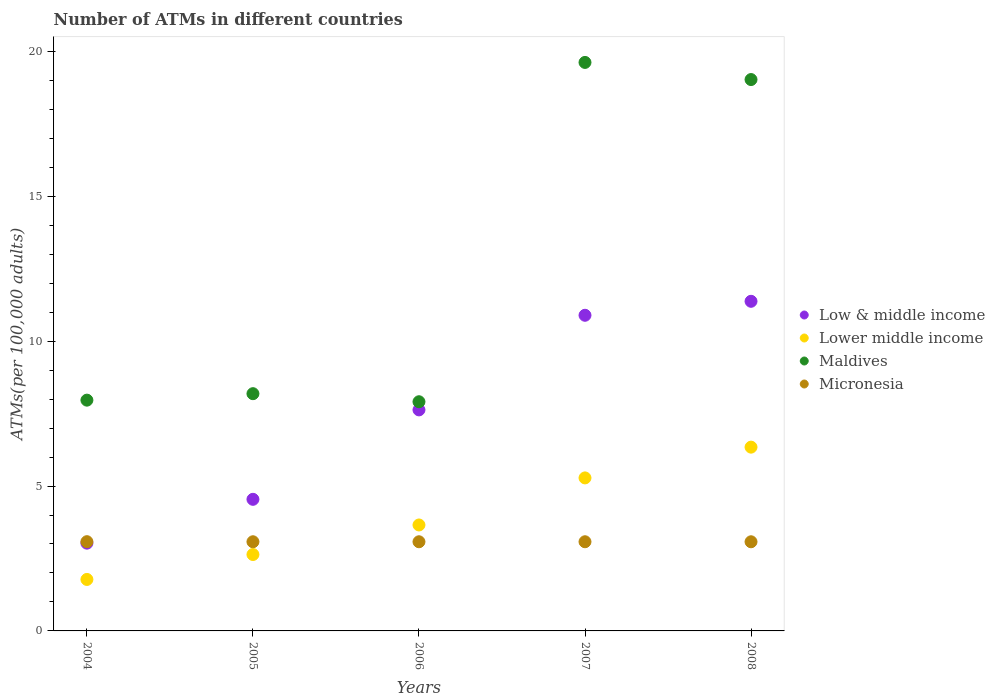Is the number of dotlines equal to the number of legend labels?
Provide a short and direct response. Yes. What is the number of ATMs in Maldives in 2006?
Your answer should be compact. 7.91. Across all years, what is the maximum number of ATMs in Lower middle income?
Give a very brief answer. 6.34. Across all years, what is the minimum number of ATMs in Lower middle income?
Provide a succinct answer. 1.78. In which year was the number of ATMs in Lower middle income maximum?
Your response must be concise. 2008. In which year was the number of ATMs in Maldives minimum?
Provide a short and direct response. 2006. What is the total number of ATMs in Maldives in the graph?
Give a very brief answer. 62.71. What is the difference between the number of ATMs in Maldives in 2005 and that in 2007?
Provide a short and direct response. -11.43. What is the difference between the number of ATMs in Maldives in 2008 and the number of ATMs in Low & middle income in 2007?
Provide a short and direct response. 8.13. What is the average number of ATMs in Maldives per year?
Give a very brief answer. 12.54. In the year 2006, what is the difference between the number of ATMs in Maldives and number of ATMs in Low & middle income?
Keep it short and to the point. 0.28. What is the ratio of the number of ATMs in Low & middle income in 2005 to that in 2007?
Your answer should be compact. 0.42. Is the number of ATMs in Micronesia in 2004 less than that in 2006?
Give a very brief answer. No. Is the difference between the number of ATMs in Maldives in 2004 and 2006 greater than the difference between the number of ATMs in Low & middle income in 2004 and 2006?
Make the answer very short. Yes. What is the difference between the highest and the second highest number of ATMs in Micronesia?
Give a very brief answer. 0. What is the difference between the highest and the lowest number of ATMs in Maldives?
Ensure brevity in your answer.  11.71. Is it the case that in every year, the sum of the number of ATMs in Maldives and number of ATMs in Lower middle income  is greater than the number of ATMs in Low & middle income?
Your answer should be very brief. Yes. How many dotlines are there?
Provide a short and direct response. 4. How many years are there in the graph?
Ensure brevity in your answer.  5. What is the difference between two consecutive major ticks on the Y-axis?
Make the answer very short. 5. Are the values on the major ticks of Y-axis written in scientific E-notation?
Ensure brevity in your answer.  No. Does the graph contain any zero values?
Offer a terse response. No. What is the title of the graph?
Your response must be concise. Number of ATMs in different countries. What is the label or title of the X-axis?
Provide a short and direct response. Years. What is the label or title of the Y-axis?
Give a very brief answer. ATMs(per 100,0 adults). What is the ATMs(per 100,000 adults) of Low & middle income in 2004?
Keep it short and to the point. 3.03. What is the ATMs(per 100,000 adults) of Lower middle income in 2004?
Provide a succinct answer. 1.78. What is the ATMs(per 100,000 adults) in Maldives in 2004?
Your answer should be compact. 7.96. What is the ATMs(per 100,000 adults) in Micronesia in 2004?
Your answer should be compact. 3.08. What is the ATMs(per 100,000 adults) of Low & middle income in 2005?
Your answer should be very brief. 4.54. What is the ATMs(per 100,000 adults) of Lower middle income in 2005?
Your answer should be very brief. 2.64. What is the ATMs(per 100,000 adults) of Maldives in 2005?
Make the answer very short. 8.19. What is the ATMs(per 100,000 adults) in Micronesia in 2005?
Provide a short and direct response. 3.08. What is the ATMs(per 100,000 adults) of Low & middle income in 2006?
Offer a terse response. 7.63. What is the ATMs(per 100,000 adults) of Lower middle income in 2006?
Your response must be concise. 3.66. What is the ATMs(per 100,000 adults) in Maldives in 2006?
Provide a short and direct response. 7.91. What is the ATMs(per 100,000 adults) of Micronesia in 2006?
Keep it short and to the point. 3.08. What is the ATMs(per 100,000 adults) in Low & middle income in 2007?
Offer a very short reply. 10.89. What is the ATMs(per 100,000 adults) in Lower middle income in 2007?
Keep it short and to the point. 5.28. What is the ATMs(per 100,000 adults) of Maldives in 2007?
Your answer should be compact. 19.62. What is the ATMs(per 100,000 adults) of Micronesia in 2007?
Ensure brevity in your answer.  3.08. What is the ATMs(per 100,000 adults) of Low & middle income in 2008?
Make the answer very short. 11.38. What is the ATMs(per 100,000 adults) of Lower middle income in 2008?
Ensure brevity in your answer.  6.34. What is the ATMs(per 100,000 adults) of Maldives in 2008?
Provide a succinct answer. 19.03. What is the ATMs(per 100,000 adults) in Micronesia in 2008?
Keep it short and to the point. 3.08. Across all years, what is the maximum ATMs(per 100,000 adults) of Low & middle income?
Offer a very short reply. 11.38. Across all years, what is the maximum ATMs(per 100,000 adults) of Lower middle income?
Ensure brevity in your answer.  6.34. Across all years, what is the maximum ATMs(per 100,000 adults) of Maldives?
Your answer should be compact. 19.62. Across all years, what is the maximum ATMs(per 100,000 adults) in Micronesia?
Give a very brief answer. 3.08. Across all years, what is the minimum ATMs(per 100,000 adults) in Low & middle income?
Your response must be concise. 3.03. Across all years, what is the minimum ATMs(per 100,000 adults) in Lower middle income?
Keep it short and to the point. 1.78. Across all years, what is the minimum ATMs(per 100,000 adults) in Maldives?
Offer a terse response. 7.91. Across all years, what is the minimum ATMs(per 100,000 adults) in Micronesia?
Keep it short and to the point. 3.08. What is the total ATMs(per 100,000 adults) of Low & middle income in the graph?
Your answer should be compact. 37.47. What is the total ATMs(per 100,000 adults) of Lower middle income in the graph?
Your answer should be very brief. 19.69. What is the total ATMs(per 100,000 adults) in Maldives in the graph?
Give a very brief answer. 62.71. What is the total ATMs(per 100,000 adults) of Micronesia in the graph?
Provide a succinct answer. 15.39. What is the difference between the ATMs(per 100,000 adults) in Low & middle income in 2004 and that in 2005?
Offer a very short reply. -1.51. What is the difference between the ATMs(per 100,000 adults) in Lower middle income in 2004 and that in 2005?
Provide a succinct answer. -0.86. What is the difference between the ATMs(per 100,000 adults) of Maldives in 2004 and that in 2005?
Offer a very short reply. -0.22. What is the difference between the ATMs(per 100,000 adults) in Micronesia in 2004 and that in 2005?
Ensure brevity in your answer.  0. What is the difference between the ATMs(per 100,000 adults) in Low & middle income in 2004 and that in 2006?
Your answer should be very brief. -4.6. What is the difference between the ATMs(per 100,000 adults) in Lower middle income in 2004 and that in 2006?
Ensure brevity in your answer.  -1.88. What is the difference between the ATMs(per 100,000 adults) of Maldives in 2004 and that in 2006?
Offer a very short reply. 0.05. What is the difference between the ATMs(per 100,000 adults) of Micronesia in 2004 and that in 2006?
Keep it short and to the point. 0. What is the difference between the ATMs(per 100,000 adults) in Low & middle income in 2004 and that in 2007?
Make the answer very short. -7.86. What is the difference between the ATMs(per 100,000 adults) of Lower middle income in 2004 and that in 2007?
Ensure brevity in your answer.  -3.5. What is the difference between the ATMs(per 100,000 adults) in Maldives in 2004 and that in 2007?
Your answer should be very brief. -11.66. What is the difference between the ATMs(per 100,000 adults) in Micronesia in 2004 and that in 2007?
Your answer should be compact. 0. What is the difference between the ATMs(per 100,000 adults) of Low & middle income in 2004 and that in 2008?
Give a very brief answer. -8.35. What is the difference between the ATMs(per 100,000 adults) of Lower middle income in 2004 and that in 2008?
Offer a terse response. -4.57. What is the difference between the ATMs(per 100,000 adults) in Maldives in 2004 and that in 2008?
Ensure brevity in your answer.  -11.06. What is the difference between the ATMs(per 100,000 adults) of Micronesia in 2004 and that in 2008?
Offer a very short reply. 0. What is the difference between the ATMs(per 100,000 adults) of Low & middle income in 2005 and that in 2006?
Offer a very short reply. -3.09. What is the difference between the ATMs(per 100,000 adults) of Lower middle income in 2005 and that in 2006?
Provide a short and direct response. -1.02. What is the difference between the ATMs(per 100,000 adults) in Maldives in 2005 and that in 2006?
Give a very brief answer. 0.28. What is the difference between the ATMs(per 100,000 adults) in Low & middle income in 2005 and that in 2007?
Provide a succinct answer. -6.35. What is the difference between the ATMs(per 100,000 adults) of Lower middle income in 2005 and that in 2007?
Your response must be concise. -2.64. What is the difference between the ATMs(per 100,000 adults) of Maldives in 2005 and that in 2007?
Your answer should be very brief. -11.43. What is the difference between the ATMs(per 100,000 adults) in Micronesia in 2005 and that in 2007?
Your answer should be very brief. -0. What is the difference between the ATMs(per 100,000 adults) in Low & middle income in 2005 and that in 2008?
Make the answer very short. -6.83. What is the difference between the ATMs(per 100,000 adults) of Lower middle income in 2005 and that in 2008?
Your answer should be compact. -3.71. What is the difference between the ATMs(per 100,000 adults) in Maldives in 2005 and that in 2008?
Give a very brief answer. -10.84. What is the difference between the ATMs(per 100,000 adults) of Micronesia in 2005 and that in 2008?
Keep it short and to the point. 0. What is the difference between the ATMs(per 100,000 adults) of Low & middle income in 2006 and that in 2007?
Offer a very short reply. -3.27. What is the difference between the ATMs(per 100,000 adults) in Lower middle income in 2006 and that in 2007?
Ensure brevity in your answer.  -1.62. What is the difference between the ATMs(per 100,000 adults) in Maldives in 2006 and that in 2007?
Your answer should be compact. -11.71. What is the difference between the ATMs(per 100,000 adults) in Micronesia in 2006 and that in 2007?
Provide a short and direct response. -0. What is the difference between the ATMs(per 100,000 adults) of Low & middle income in 2006 and that in 2008?
Ensure brevity in your answer.  -3.75. What is the difference between the ATMs(per 100,000 adults) in Lower middle income in 2006 and that in 2008?
Offer a very short reply. -2.69. What is the difference between the ATMs(per 100,000 adults) in Maldives in 2006 and that in 2008?
Provide a succinct answer. -11.12. What is the difference between the ATMs(per 100,000 adults) in Low & middle income in 2007 and that in 2008?
Provide a short and direct response. -0.48. What is the difference between the ATMs(per 100,000 adults) in Lower middle income in 2007 and that in 2008?
Provide a succinct answer. -1.06. What is the difference between the ATMs(per 100,000 adults) of Maldives in 2007 and that in 2008?
Give a very brief answer. 0.59. What is the difference between the ATMs(per 100,000 adults) in Micronesia in 2007 and that in 2008?
Offer a very short reply. 0. What is the difference between the ATMs(per 100,000 adults) of Low & middle income in 2004 and the ATMs(per 100,000 adults) of Lower middle income in 2005?
Your answer should be very brief. 0.39. What is the difference between the ATMs(per 100,000 adults) of Low & middle income in 2004 and the ATMs(per 100,000 adults) of Maldives in 2005?
Your answer should be compact. -5.16. What is the difference between the ATMs(per 100,000 adults) in Low & middle income in 2004 and the ATMs(per 100,000 adults) in Micronesia in 2005?
Ensure brevity in your answer.  -0.05. What is the difference between the ATMs(per 100,000 adults) in Lower middle income in 2004 and the ATMs(per 100,000 adults) in Maldives in 2005?
Make the answer very short. -6.41. What is the difference between the ATMs(per 100,000 adults) in Lower middle income in 2004 and the ATMs(per 100,000 adults) in Micronesia in 2005?
Offer a very short reply. -1.3. What is the difference between the ATMs(per 100,000 adults) in Maldives in 2004 and the ATMs(per 100,000 adults) in Micronesia in 2005?
Provide a succinct answer. 4.89. What is the difference between the ATMs(per 100,000 adults) of Low & middle income in 2004 and the ATMs(per 100,000 adults) of Lower middle income in 2006?
Your response must be concise. -0.63. What is the difference between the ATMs(per 100,000 adults) in Low & middle income in 2004 and the ATMs(per 100,000 adults) in Maldives in 2006?
Keep it short and to the point. -4.88. What is the difference between the ATMs(per 100,000 adults) in Low & middle income in 2004 and the ATMs(per 100,000 adults) in Micronesia in 2006?
Your answer should be very brief. -0.05. What is the difference between the ATMs(per 100,000 adults) in Lower middle income in 2004 and the ATMs(per 100,000 adults) in Maldives in 2006?
Your response must be concise. -6.13. What is the difference between the ATMs(per 100,000 adults) of Lower middle income in 2004 and the ATMs(per 100,000 adults) of Micronesia in 2006?
Your response must be concise. -1.3. What is the difference between the ATMs(per 100,000 adults) in Maldives in 2004 and the ATMs(per 100,000 adults) in Micronesia in 2006?
Your answer should be compact. 4.89. What is the difference between the ATMs(per 100,000 adults) of Low & middle income in 2004 and the ATMs(per 100,000 adults) of Lower middle income in 2007?
Offer a terse response. -2.25. What is the difference between the ATMs(per 100,000 adults) of Low & middle income in 2004 and the ATMs(per 100,000 adults) of Maldives in 2007?
Offer a very short reply. -16.59. What is the difference between the ATMs(per 100,000 adults) of Low & middle income in 2004 and the ATMs(per 100,000 adults) of Micronesia in 2007?
Provide a succinct answer. -0.05. What is the difference between the ATMs(per 100,000 adults) of Lower middle income in 2004 and the ATMs(per 100,000 adults) of Maldives in 2007?
Give a very brief answer. -17.84. What is the difference between the ATMs(per 100,000 adults) of Lower middle income in 2004 and the ATMs(per 100,000 adults) of Micronesia in 2007?
Offer a terse response. -1.3. What is the difference between the ATMs(per 100,000 adults) of Maldives in 2004 and the ATMs(per 100,000 adults) of Micronesia in 2007?
Provide a succinct answer. 4.89. What is the difference between the ATMs(per 100,000 adults) of Low & middle income in 2004 and the ATMs(per 100,000 adults) of Lower middle income in 2008?
Keep it short and to the point. -3.31. What is the difference between the ATMs(per 100,000 adults) of Low & middle income in 2004 and the ATMs(per 100,000 adults) of Maldives in 2008?
Provide a short and direct response. -16. What is the difference between the ATMs(per 100,000 adults) in Low & middle income in 2004 and the ATMs(per 100,000 adults) in Micronesia in 2008?
Offer a terse response. -0.05. What is the difference between the ATMs(per 100,000 adults) of Lower middle income in 2004 and the ATMs(per 100,000 adults) of Maldives in 2008?
Keep it short and to the point. -17.25. What is the difference between the ATMs(per 100,000 adults) in Lower middle income in 2004 and the ATMs(per 100,000 adults) in Micronesia in 2008?
Keep it short and to the point. -1.3. What is the difference between the ATMs(per 100,000 adults) in Maldives in 2004 and the ATMs(per 100,000 adults) in Micronesia in 2008?
Ensure brevity in your answer.  4.89. What is the difference between the ATMs(per 100,000 adults) of Low & middle income in 2005 and the ATMs(per 100,000 adults) of Lower middle income in 2006?
Your response must be concise. 0.89. What is the difference between the ATMs(per 100,000 adults) of Low & middle income in 2005 and the ATMs(per 100,000 adults) of Maldives in 2006?
Provide a succinct answer. -3.37. What is the difference between the ATMs(per 100,000 adults) of Low & middle income in 2005 and the ATMs(per 100,000 adults) of Micronesia in 2006?
Provide a short and direct response. 1.46. What is the difference between the ATMs(per 100,000 adults) in Lower middle income in 2005 and the ATMs(per 100,000 adults) in Maldives in 2006?
Make the answer very short. -5.27. What is the difference between the ATMs(per 100,000 adults) in Lower middle income in 2005 and the ATMs(per 100,000 adults) in Micronesia in 2006?
Your response must be concise. -0.44. What is the difference between the ATMs(per 100,000 adults) in Maldives in 2005 and the ATMs(per 100,000 adults) in Micronesia in 2006?
Give a very brief answer. 5.11. What is the difference between the ATMs(per 100,000 adults) of Low & middle income in 2005 and the ATMs(per 100,000 adults) of Lower middle income in 2007?
Ensure brevity in your answer.  -0.74. What is the difference between the ATMs(per 100,000 adults) of Low & middle income in 2005 and the ATMs(per 100,000 adults) of Maldives in 2007?
Your answer should be compact. -15.08. What is the difference between the ATMs(per 100,000 adults) in Low & middle income in 2005 and the ATMs(per 100,000 adults) in Micronesia in 2007?
Keep it short and to the point. 1.46. What is the difference between the ATMs(per 100,000 adults) in Lower middle income in 2005 and the ATMs(per 100,000 adults) in Maldives in 2007?
Give a very brief answer. -16.98. What is the difference between the ATMs(per 100,000 adults) of Lower middle income in 2005 and the ATMs(per 100,000 adults) of Micronesia in 2007?
Keep it short and to the point. -0.44. What is the difference between the ATMs(per 100,000 adults) in Maldives in 2005 and the ATMs(per 100,000 adults) in Micronesia in 2007?
Give a very brief answer. 5.11. What is the difference between the ATMs(per 100,000 adults) in Low & middle income in 2005 and the ATMs(per 100,000 adults) in Lower middle income in 2008?
Your answer should be compact. -1.8. What is the difference between the ATMs(per 100,000 adults) in Low & middle income in 2005 and the ATMs(per 100,000 adults) in Maldives in 2008?
Your answer should be compact. -14.49. What is the difference between the ATMs(per 100,000 adults) in Low & middle income in 2005 and the ATMs(per 100,000 adults) in Micronesia in 2008?
Your response must be concise. 1.47. What is the difference between the ATMs(per 100,000 adults) of Lower middle income in 2005 and the ATMs(per 100,000 adults) of Maldives in 2008?
Make the answer very short. -16.39. What is the difference between the ATMs(per 100,000 adults) of Lower middle income in 2005 and the ATMs(per 100,000 adults) of Micronesia in 2008?
Provide a short and direct response. -0.44. What is the difference between the ATMs(per 100,000 adults) of Maldives in 2005 and the ATMs(per 100,000 adults) of Micronesia in 2008?
Ensure brevity in your answer.  5.11. What is the difference between the ATMs(per 100,000 adults) in Low & middle income in 2006 and the ATMs(per 100,000 adults) in Lower middle income in 2007?
Your answer should be very brief. 2.35. What is the difference between the ATMs(per 100,000 adults) of Low & middle income in 2006 and the ATMs(per 100,000 adults) of Maldives in 2007?
Your response must be concise. -11.99. What is the difference between the ATMs(per 100,000 adults) of Low & middle income in 2006 and the ATMs(per 100,000 adults) of Micronesia in 2007?
Give a very brief answer. 4.55. What is the difference between the ATMs(per 100,000 adults) in Lower middle income in 2006 and the ATMs(per 100,000 adults) in Maldives in 2007?
Offer a terse response. -15.96. What is the difference between the ATMs(per 100,000 adults) of Lower middle income in 2006 and the ATMs(per 100,000 adults) of Micronesia in 2007?
Offer a terse response. 0.58. What is the difference between the ATMs(per 100,000 adults) of Maldives in 2006 and the ATMs(per 100,000 adults) of Micronesia in 2007?
Provide a succinct answer. 4.83. What is the difference between the ATMs(per 100,000 adults) in Low & middle income in 2006 and the ATMs(per 100,000 adults) in Lower middle income in 2008?
Keep it short and to the point. 1.29. What is the difference between the ATMs(per 100,000 adults) of Low & middle income in 2006 and the ATMs(per 100,000 adults) of Maldives in 2008?
Provide a short and direct response. -11.4. What is the difference between the ATMs(per 100,000 adults) of Low & middle income in 2006 and the ATMs(per 100,000 adults) of Micronesia in 2008?
Offer a terse response. 4.55. What is the difference between the ATMs(per 100,000 adults) of Lower middle income in 2006 and the ATMs(per 100,000 adults) of Maldives in 2008?
Your answer should be very brief. -15.37. What is the difference between the ATMs(per 100,000 adults) of Lower middle income in 2006 and the ATMs(per 100,000 adults) of Micronesia in 2008?
Offer a very short reply. 0.58. What is the difference between the ATMs(per 100,000 adults) in Maldives in 2006 and the ATMs(per 100,000 adults) in Micronesia in 2008?
Your response must be concise. 4.83. What is the difference between the ATMs(per 100,000 adults) in Low & middle income in 2007 and the ATMs(per 100,000 adults) in Lower middle income in 2008?
Ensure brevity in your answer.  4.55. What is the difference between the ATMs(per 100,000 adults) of Low & middle income in 2007 and the ATMs(per 100,000 adults) of Maldives in 2008?
Your answer should be compact. -8.13. What is the difference between the ATMs(per 100,000 adults) in Low & middle income in 2007 and the ATMs(per 100,000 adults) in Micronesia in 2008?
Your answer should be compact. 7.82. What is the difference between the ATMs(per 100,000 adults) of Lower middle income in 2007 and the ATMs(per 100,000 adults) of Maldives in 2008?
Provide a short and direct response. -13.75. What is the difference between the ATMs(per 100,000 adults) in Lower middle income in 2007 and the ATMs(per 100,000 adults) in Micronesia in 2008?
Provide a succinct answer. 2.2. What is the difference between the ATMs(per 100,000 adults) in Maldives in 2007 and the ATMs(per 100,000 adults) in Micronesia in 2008?
Make the answer very short. 16.54. What is the average ATMs(per 100,000 adults) in Low & middle income per year?
Ensure brevity in your answer.  7.49. What is the average ATMs(per 100,000 adults) in Lower middle income per year?
Ensure brevity in your answer.  3.94. What is the average ATMs(per 100,000 adults) of Maldives per year?
Ensure brevity in your answer.  12.54. What is the average ATMs(per 100,000 adults) in Micronesia per year?
Make the answer very short. 3.08. In the year 2004, what is the difference between the ATMs(per 100,000 adults) in Low & middle income and ATMs(per 100,000 adults) in Lower middle income?
Ensure brevity in your answer.  1.25. In the year 2004, what is the difference between the ATMs(per 100,000 adults) in Low & middle income and ATMs(per 100,000 adults) in Maldives?
Your answer should be very brief. -4.93. In the year 2004, what is the difference between the ATMs(per 100,000 adults) in Low & middle income and ATMs(per 100,000 adults) in Micronesia?
Your answer should be compact. -0.05. In the year 2004, what is the difference between the ATMs(per 100,000 adults) in Lower middle income and ATMs(per 100,000 adults) in Maldives?
Make the answer very short. -6.19. In the year 2004, what is the difference between the ATMs(per 100,000 adults) in Lower middle income and ATMs(per 100,000 adults) in Micronesia?
Provide a short and direct response. -1.3. In the year 2004, what is the difference between the ATMs(per 100,000 adults) of Maldives and ATMs(per 100,000 adults) of Micronesia?
Offer a terse response. 4.88. In the year 2005, what is the difference between the ATMs(per 100,000 adults) of Low & middle income and ATMs(per 100,000 adults) of Lower middle income?
Keep it short and to the point. 1.9. In the year 2005, what is the difference between the ATMs(per 100,000 adults) of Low & middle income and ATMs(per 100,000 adults) of Maldives?
Your answer should be very brief. -3.65. In the year 2005, what is the difference between the ATMs(per 100,000 adults) of Low & middle income and ATMs(per 100,000 adults) of Micronesia?
Offer a very short reply. 1.46. In the year 2005, what is the difference between the ATMs(per 100,000 adults) in Lower middle income and ATMs(per 100,000 adults) in Maldives?
Offer a terse response. -5.55. In the year 2005, what is the difference between the ATMs(per 100,000 adults) of Lower middle income and ATMs(per 100,000 adults) of Micronesia?
Offer a very short reply. -0.44. In the year 2005, what is the difference between the ATMs(per 100,000 adults) of Maldives and ATMs(per 100,000 adults) of Micronesia?
Ensure brevity in your answer.  5.11. In the year 2006, what is the difference between the ATMs(per 100,000 adults) in Low & middle income and ATMs(per 100,000 adults) in Lower middle income?
Ensure brevity in your answer.  3.97. In the year 2006, what is the difference between the ATMs(per 100,000 adults) of Low & middle income and ATMs(per 100,000 adults) of Maldives?
Offer a terse response. -0.28. In the year 2006, what is the difference between the ATMs(per 100,000 adults) of Low & middle income and ATMs(per 100,000 adults) of Micronesia?
Make the answer very short. 4.55. In the year 2006, what is the difference between the ATMs(per 100,000 adults) of Lower middle income and ATMs(per 100,000 adults) of Maldives?
Give a very brief answer. -4.25. In the year 2006, what is the difference between the ATMs(per 100,000 adults) in Lower middle income and ATMs(per 100,000 adults) in Micronesia?
Offer a terse response. 0.58. In the year 2006, what is the difference between the ATMs(per 100,000 adults) of Maldives and ATMs(per 100,000 adults) of Micronesia?
Your response must be concise. 4.83. In the year 2007, what is the difference between the ATMs(per 100,000 adults) of Low & middle income and ATMs(per 100,000 adults) of Lower middle income?
Keep it short and to the point. 5.61. In the year 2007, what is the difference between the ATMs(per 100,000 adults) of Low & middle income and ATMs(per 100,000 adults) of Maldives?
Your answer should be compact. -8.73. In the year 2007, what is the difference between the ATMs(per 100,000 adults) in Low & middle income and ATMs(per 100,000 adults) in Micronesia?
Keep it short and to the point. 7.82. In the year 2007, what is the difference between the ATMs(per 100,000 adults) of Lower middle income and ATMs(per 100,000 adults) of Maldives?
Make the answer very short. -14.34. In the year 2007, what is the difference between the ATMs(per 100,000 adults) in Lower middle income and ATMs(per 100,000 adults) in Micronesia?
Offer a very short reply. 2.2. In the year 2007, what is the difference between the ATMs(per 100,000 adults) of Maldives and ATMs(per 100,000 adults) of Micronesia?
Make the answer very short. 16.54. In the year 2008, what is the difference between the ATMs(per 100,000 adults) of Low & middle income and ATMs(per 100,000 adults) of Lower middle income?
Your response must be concise. 5.03. In the year 2008, what is the difference between the ATMs(per 100,000 adults) in Low & middle income and ATMs(per 100,000 adults) in Maldives?
Provide a succinct answer. -7.65. In the year 2008, what is the difference between the ATMs(per 100,000 adults) in Low & middle income and ATMs(per 100,000 adults) in Micronesia?
Give a very brief answer. 8.3. In the year 2008, what is the difference between the ATMs(per 100,000 adults) in Lower middle income and ATMs(per 100,000 adults) in Maldives?
Give a very brief answer. -12.69. In the year 2008, what is the difference between the ATMs(per 100,000 adults) of Lower middle income and ATMs(per 100,000 adults) of Micronesia?
Provide a short and direct response. 3.27. In the year 2008, what is the difference between the ATMs(per 100,000 adults) of Maldives and ATMs(per 100,000 adults) of Micronesia?
Provide a short and direct response. 15.95. What is the ratio of the ATMs(per 100,000 adults) of Low & middle income in 2004 to that in 2005?
Provide a succinct answer. 0.67. What is the ratio of the ATMs(per 100,000 adults) in Lower middle income in 2004 to that in 2005?
Provide a succinct answer. 0.67. What is the ratio of the ATMs(per 100,000 adults) of Maldives in 2004 to that in 2005?
Keep it short and to the point. 0.97. What is the ratio of the ATMs(per 100,000 adults) of Low & middle income in 2004 to that in 2006?
Ensure brevity in your answer.  0.4. What is the ratio of the ATMs(per 100,000 adults) of Lower middle income in 2004 to that in 2006?
Your response must be concise. 0.49. What is the ratio of the ATMs(per 100,000 adults) of Micronesia in 2004 to that in 2006?
Provide a succinct answer. 1. What is the ratio of the ATMs(per 100,000 adults) in Low & middle income in 2004 to that in 2007?
Ensure brevity in your answer.  0.28. What is the ratio of the ATMs(per 100,000 adults) of Lower middle income in 2004 to that in 2007?
Keep it short and to the point. 0.34. What is the ratio of the ATMs(per 100,000 adults) of Maldives in 2004 to that in 2007?
Provide a short and direct response. 0.41. What is the ratio of the ATMs(per 100,000 adults) of Low & middle income in 2004 to that in 2008?
Provide a short and direct response. 0.27. What is the ratio of the ATMs(per 100,000 adults) of Lower middle income in 2004 to that in 2008?
Ensure brevity in your answer.  0.28. What is the ratio of the ATMs(per 100,000 adults) in Maldives in 2004 to that in 2008?
Provide a short and direct response. 0.42. What is the ratio of the ATMs(per 100,000 adults) of Low & middle income in 2005 to that in 2006?
Your response must be concise. 0.6. What is the ratio of the ATMs(per 100,000 adults) of Lower middle income in 2005 to that in 2006?
Make the answer very short. 0.72. What is the ratio of the ATMs(per 100,000 adults) in Maldives in 2005 to that in 2006?
Make the answer very short. 1.04. What is the ratio of the ATMs(per 100,000 adults) in Low & middle income in 2005 to that in 2007?
Provide a succinct answer. 0.42. What is the ratio of the ATMs(per 100,000 adults) in Lower middle income in 2005 to that in 2007?
Offer a terse response. 0.5. What is the ratio of the ATMs(per 100,000 adults) of Maldives in 2005 to that in 2007?
Your response must be concise. 0.42. What is the ratio of the ATMs(per 100,000 adults) in Micronesia in 2005 to that in 2007?
Make the answer very short. 1. What is the ratio of the ATMs(per 100,000 adults) in Low & middle income in 2005 to that in 2008?
Your answer should be very brief. 0.4. What is the ratio of the ATMs(per 100,000 adults) of Lower middle income in 2005 to that in 2008?
Your response must be concise. 0.42. What is the ratio of the ATMs(per 100,000 adults) in Maldives in 2005 to that in 2008?
Keep it short and to the point. 0.43. What is the ratio of the ATMs(per 100,000 adults) of Low & middle income in 2006 to that in 2007?
Your answer should be very brief. 0.7. What is the ratio of the ATMs(per 100,000 adults) in Lower middle income in 2006 to that in 2007?
Offer a very short reply. 0.69. What is the ratio of the ATMs(per 100,000 adults) of Maldives in 2006 to that in 2007?
Give a very brief answer. 0.4. What is the ratio of the ATMs(per 100,000 adults) in Low & middle income in 2006 to that in 2008?
Give a very brief answer. 0.67. What is the ratio of the ATMs(per 100,000 adults) in Lower middle income in 2006 to that in 2008?
Provide a short and direct response. 0.58. What is the ratio of the ATMs(per 100,000 adults) of Maldives in 2006 to that in 2008?
Offer a terse response. 0.42. What is the ratio of the ATMs(per 100,000 adults) of Low & middle income in 2007 to that in 2008?
Your answer should be compact. 0.96. What is the ratio of the ATMs(per 100,000 adults) of Lower middle income in 2007 to that in 2008?
Offer a terse response. 0.83. What is the ratio of the ATMs(per 100,000 adults) of Maldives in 2007 to that in 2008?
Make the answer very short. 1.03. What is the difference between the highest and the second highest ATMs(per 100,000 adults) of Low & middle income?
Ensure brevity in your answer.  0.48. What is the difference between the highest and the second highest ATMs(per 100,000 adults) of Lower middle income?
Your answer should be very brief. 1.06. What is the difference between the highest and the second highest ATMs(per 100,000 adults) of Maldives?
Your answer should be compact. 0.59. What is the difference between the highest and the second highest ATMs(per 100,000 adults) of Micronesia?
Keep it short and to the point. 0. What is the difference between the highest and the lowest ATMs(per 100,000 adults) in Low & middle income?
Your answer should be very brief. 8.35. What is the difference between the highest and the lowest ATMs(per 100,000 adults) of Lower middle income?
Ensure brevity in your answer.  4.57. What is the difference between the highest and the lowest ATMs(per 100,000 adults) of Maldives?
Ensure brevity in your answer.  11.71. What is the difference between the highest and the lowest ATMs(per 100,000 adults) in Micronesia?
Ensure brevity in your answer.  0. 